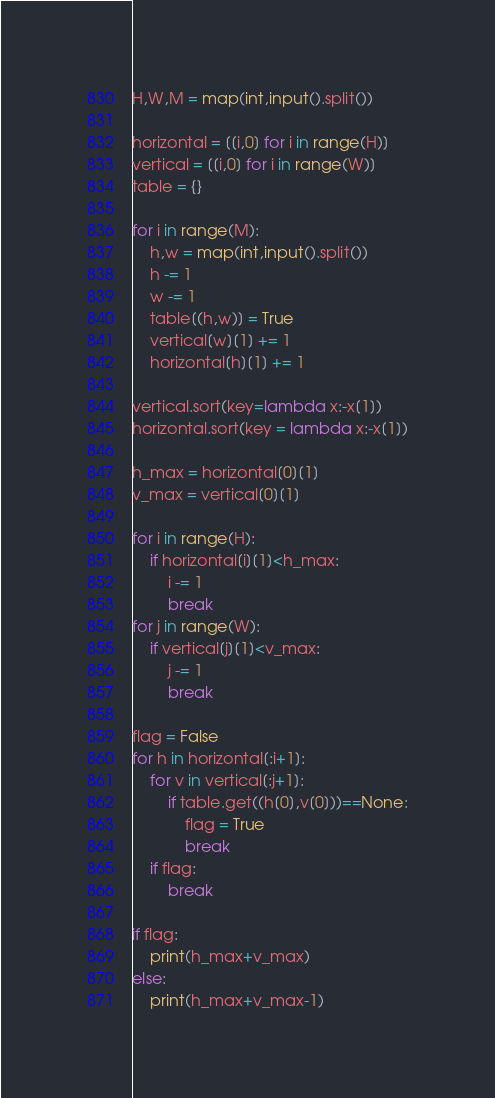<code> <loc_0><loc_0><loc_500><loc_500><_Python_>H,W,M = map(int,input().split())

horizontal = [[i,0] for i in range(H)]
vertical = [[i,0] for i in range(W)]
table = {}

for i in range(M):
    h,w = map(int,input().split())
    h -= 1
    w -= 1
    table[(h,w)] = True
    vertical[w][1] += 1
    horizontal[h][1] += 1

vertical.sort(key=lambda x:-x[1])
horizontal.sort(key = lambda x:-x[1])

h_max = horizontal[0][1]
v_max = vertical[0][1]
    
for i in range(H):
    if horizontal[i][1]<h_max:
        i -= 1
        break
for j in range(W):
    if vertical[j][1]<v_max:
        j -= 1
        break

flag = False
for h in horizontal[:i+1]:
    for v in vertical[:j+1]:
        if table.get((h[0],v[0]))==None:
            flag = True
            break
    if flag:
        break

if flag:
    print(h_max+v_max)
else:
    print(h_max+v_max-1)</code> 